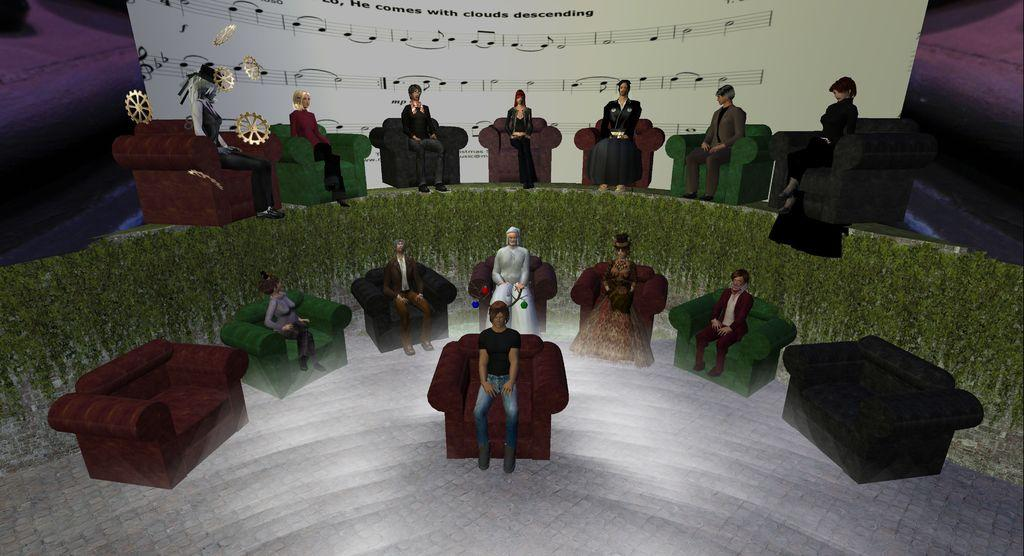What type of image is being described? The image is animated. What are the people in the image doing? The people are sitting on individual couches. What can be seen in the background of the image? There is a board in the background. What is on the board? The board has images and text on it. What color is the orange that the person is holding in the image? There is no orange present in the image; it only features people sitting on couches and a board with images and text. What type of glove is the person wearing while sitting on the couch? There is no glove visible in the image; the people are simply sitting on individual couches. 